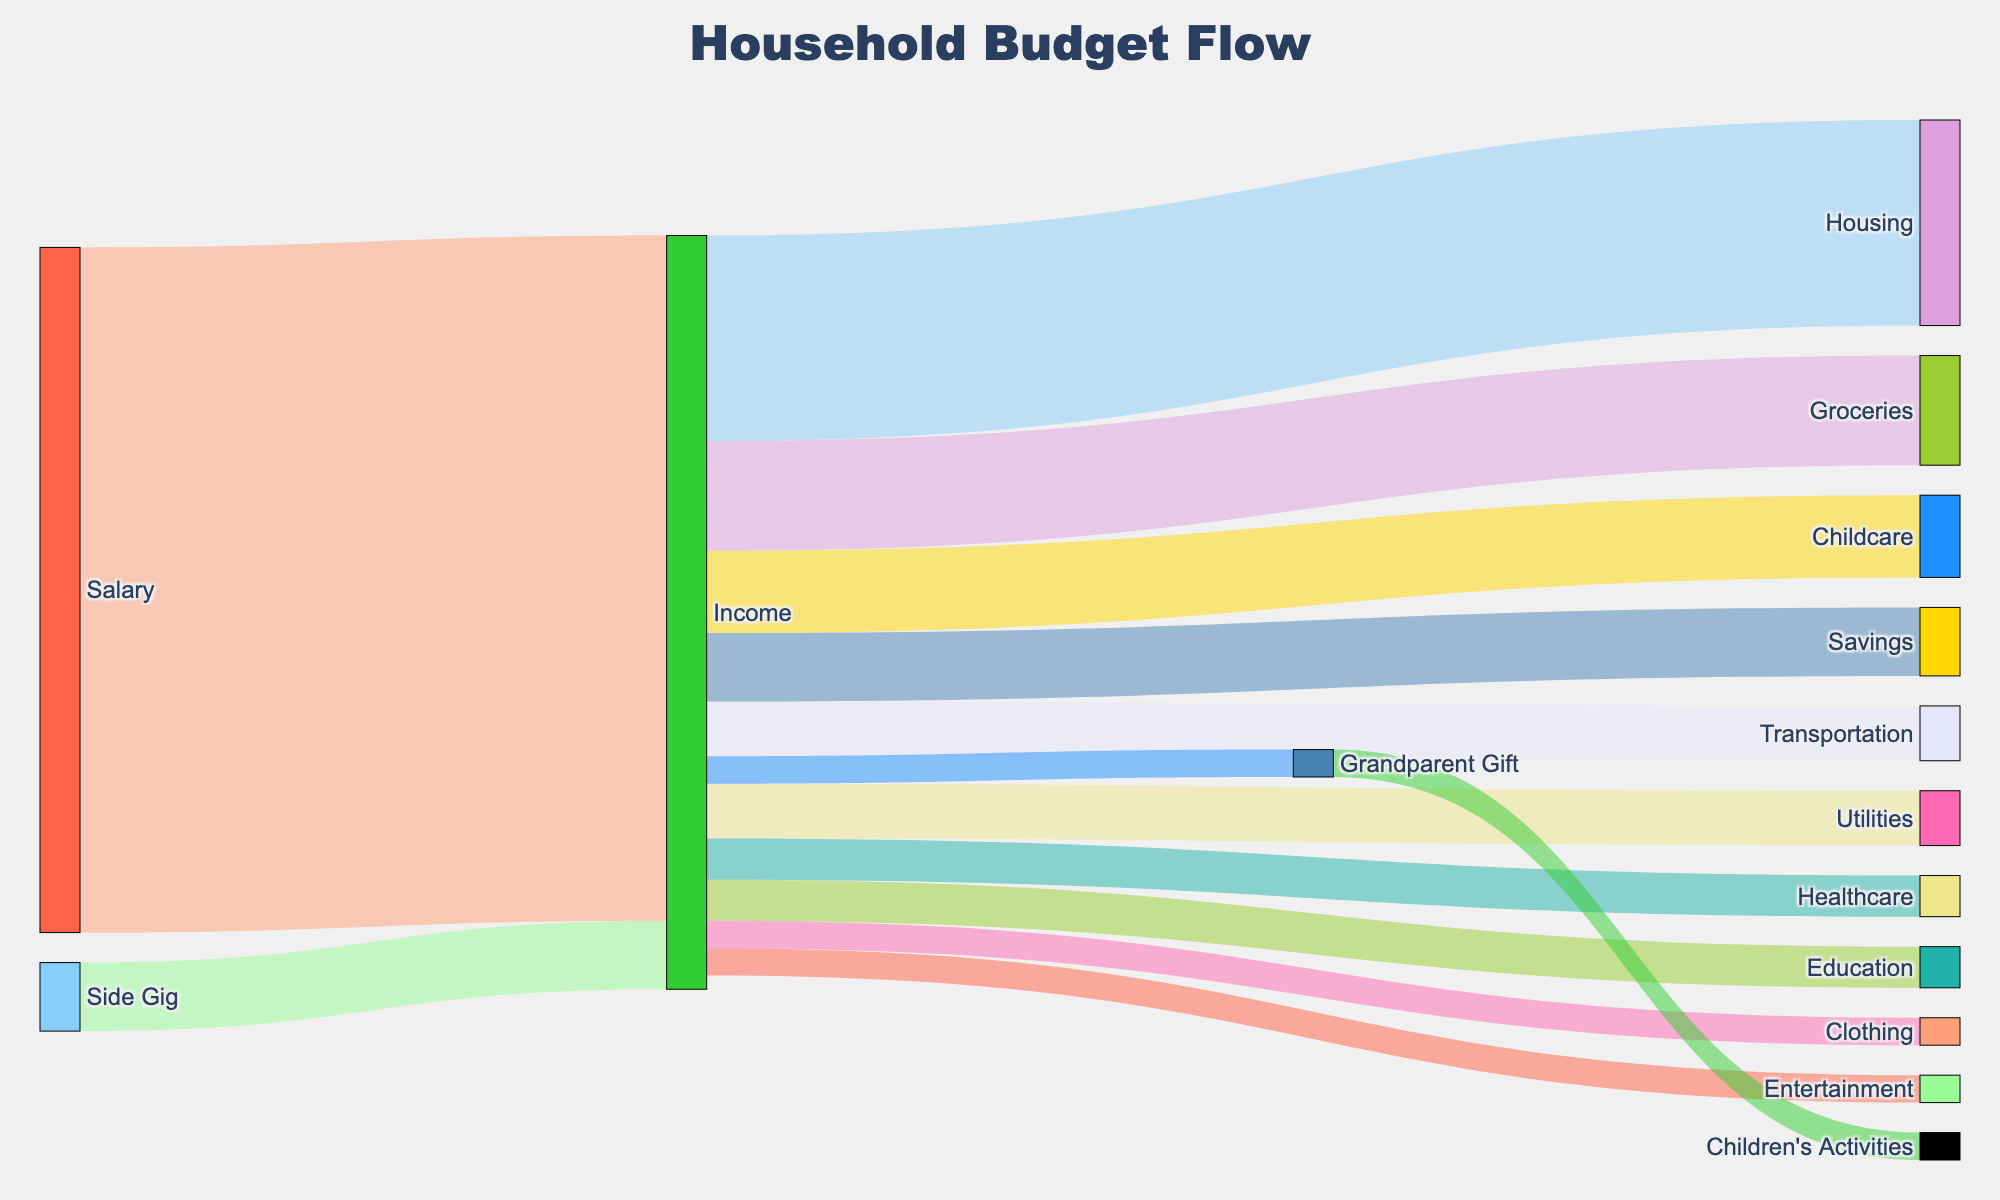What's the total household income? To find the total household income, sum the values from "Salary" and "Side Gig" that flow into "Income". The values are 5000 (Salary) + 500 (Side Gig) = 5500.
Answer: 5500 Which expense category receives the most money? Look for the thicker link under "Income" leading to the expenses. The "Housing" category receives 1500 which is the largest amount.
Answer: Housing How much money is allocated to children's activities? Locate the link from "Grandparent Gift" to "Children's Activities". The value is 200.
Answer: 200 What's the difference between the income from Salary and Side Gig? Subtract the value of "Side Gig" (500) from "Salary" (5000). The calculation is 5000 - 500 = 4500.
Answer: 4500 How much money is saved after all expenses? Sum all the outgoing values from "Income" to various expense categories and subtract this sum from the total income. The calculation is: Total Expenses = 1500 (Housing) + 800 (Groceries) + 400 (Utilities) + 400 (Transportation) + 600 (Childcare) + 300 (Healthcare) + 200 (Entertainment) + 500 (Savings) + 300 (Education) + 200 (Clothing) = 5200. Thus, Remaining Income = 5500 - 5200 = 300.
Answer: 300 Which two expense categories have the same amount allocated? Look at the values from "Income” to “Childcare" and "Education". Both receive 300.
Answer: Childcare and Education How much more is spent on Housing than on Transportation? Subtract Transportation expense (400) from Housing expense (1500). The calculation is 1500 - 400 = 1100.
Answer: 1100 What percentage of the income is allocated to Groceries? Divide the Groceries expense (800) by total income (5500) and multiply by 100. The calculation is (800 / 5500) * 100 ≈ 14.55%.
Answer: 14.55% Which has a smaller value, Utilities or Entertainment? Compare the values of "Utilities" (400) and "Entertainment" (200). "Entertainment" has a smaller value.
Answer: Entertainment How many unique categories are present in the Sankey Diagram? Count all distinct nodes ("Salary", "Side Gig", "Income", "Housing", "Groceries", "Utilities", "Transportation", "Childcare", "Healthcare", "Entertainment", "Savings", "Education", "Clothing", "Grandparent Gift", "Children's Activities"). There are 15.
Answer: 15 